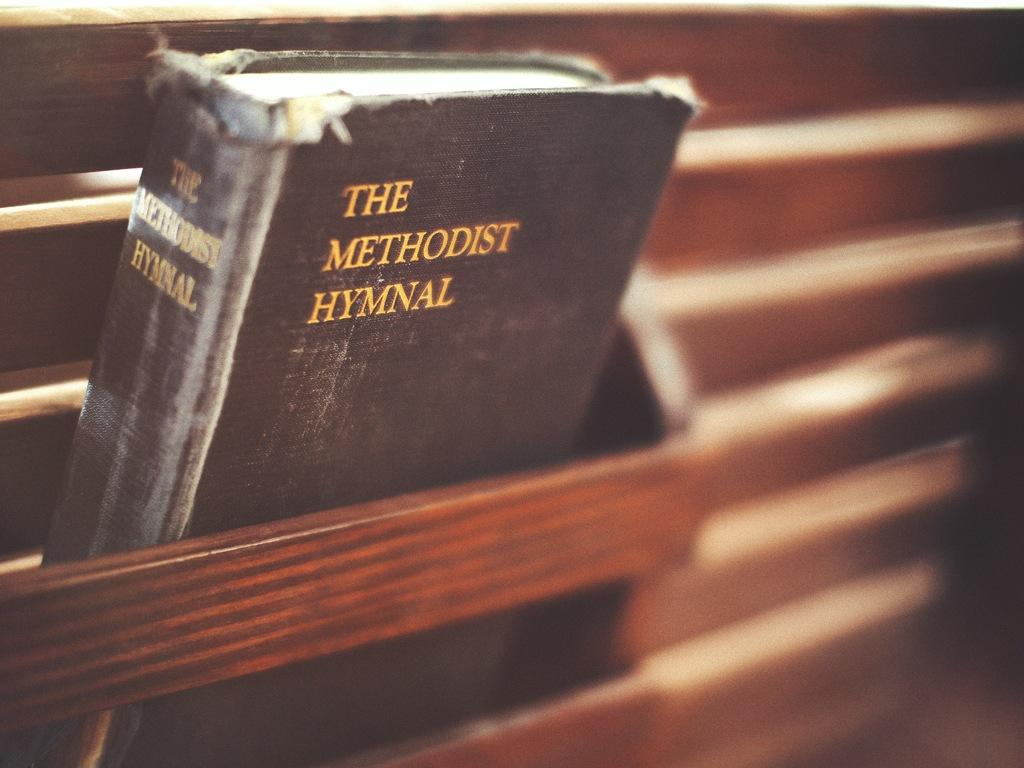<image>
Summarize the visual content of the image. An old black book titled The Methodist Hymnal. 